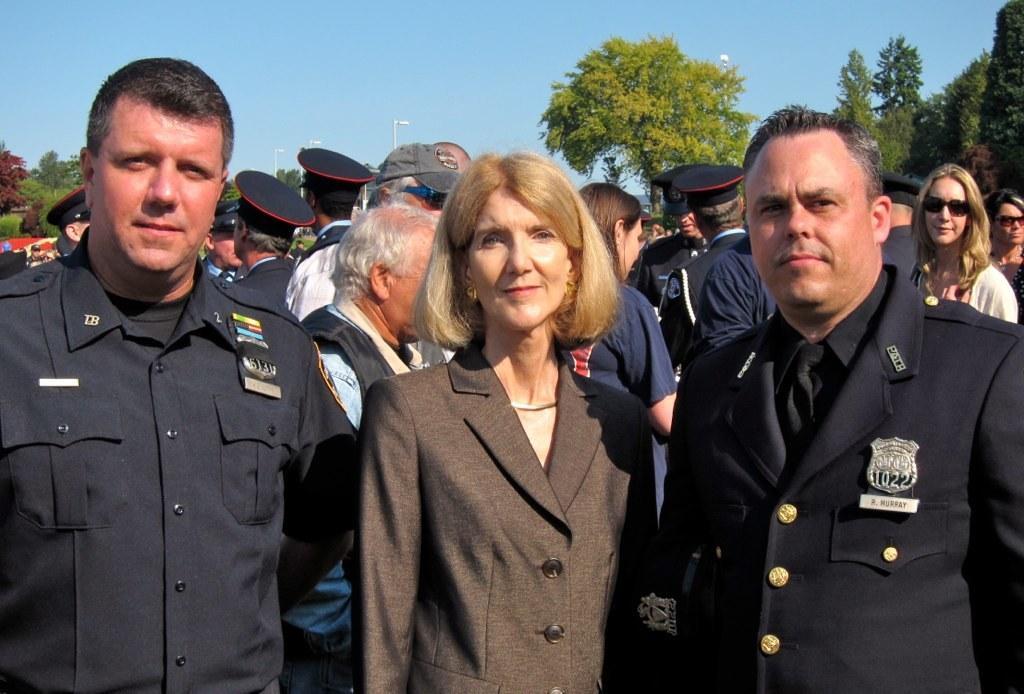Could you give a brief overview of what you see in this image? In this image there are group of people standing in which some of them are wearing uniform, behind them there are so many trees. 